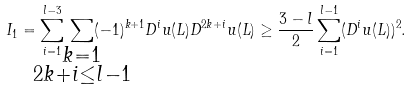<formula> <loc_0><loc_0><loc_500><loc_500>I _ { 1 } = \sum _ { i = 1 } ^ { l - 3 } \, \sum _ { \mathclap { \substack { k = 1 \\ 2 k + i \leq l - 1 } } } ( - 1 ) ^ { k + 1 } D ^ { i } u ( L ) D ^ { 2 k + i } u ( L ) \geq \frac { 3 - l } { 2 } \sum _ { i = 1 } ^ { l - 1 } ( D ^ { i } u ( L ) ) ^ { 2 } .</formula> 